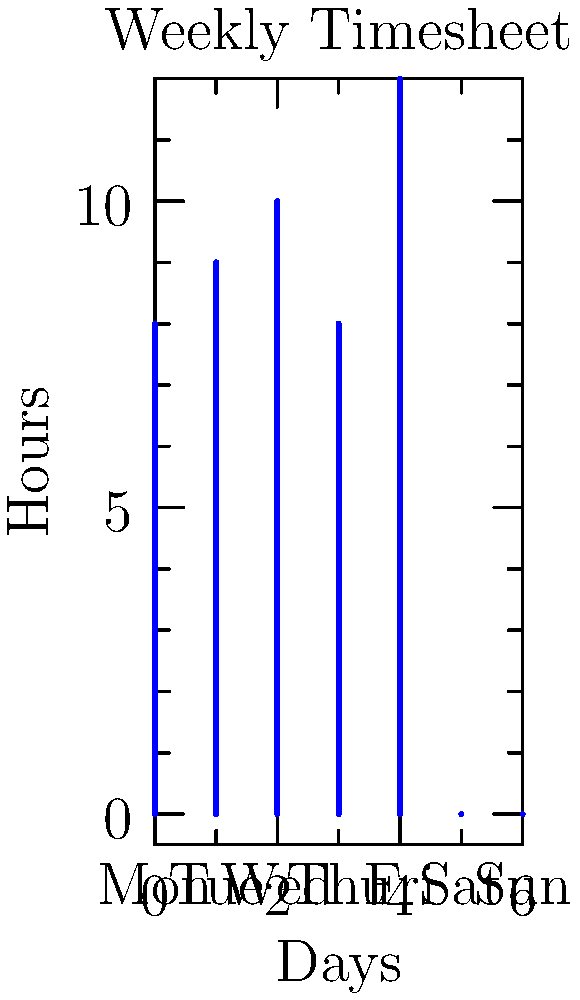Based on the weekly timesheet graph, calculate the total overtime pay for the week if the standard workweek is 40 hours, overtime is paid at 1.5 times the regular rate, and the regular hourly rate is $20. To calculate the overtime pay, we need to follow these steps:

1. Calculate total hours worked:
   $8 + 9 + 10 + 8 + 12 + 0 + 0 = 47$ hours

2. Determine overtime hours:
   $47 - 40 = 7$ overtime hours

3. Calculate overtime rate:
   Regular rate: $20/hour
   Overtime rate: $20 \times 1.5 = $30/hour

4. Calculate total overtime pay:
   $7 \text{ hours} \times $30/\text{hour} = $210$

Therefore, the total overtime pay for the week is $210.
Answer: $210 